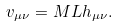<formula> <loc_0><loc_0><loc_500><loc_500>v _ { \mu \nu } = M L h _ { \mu \nu } .</formula> 